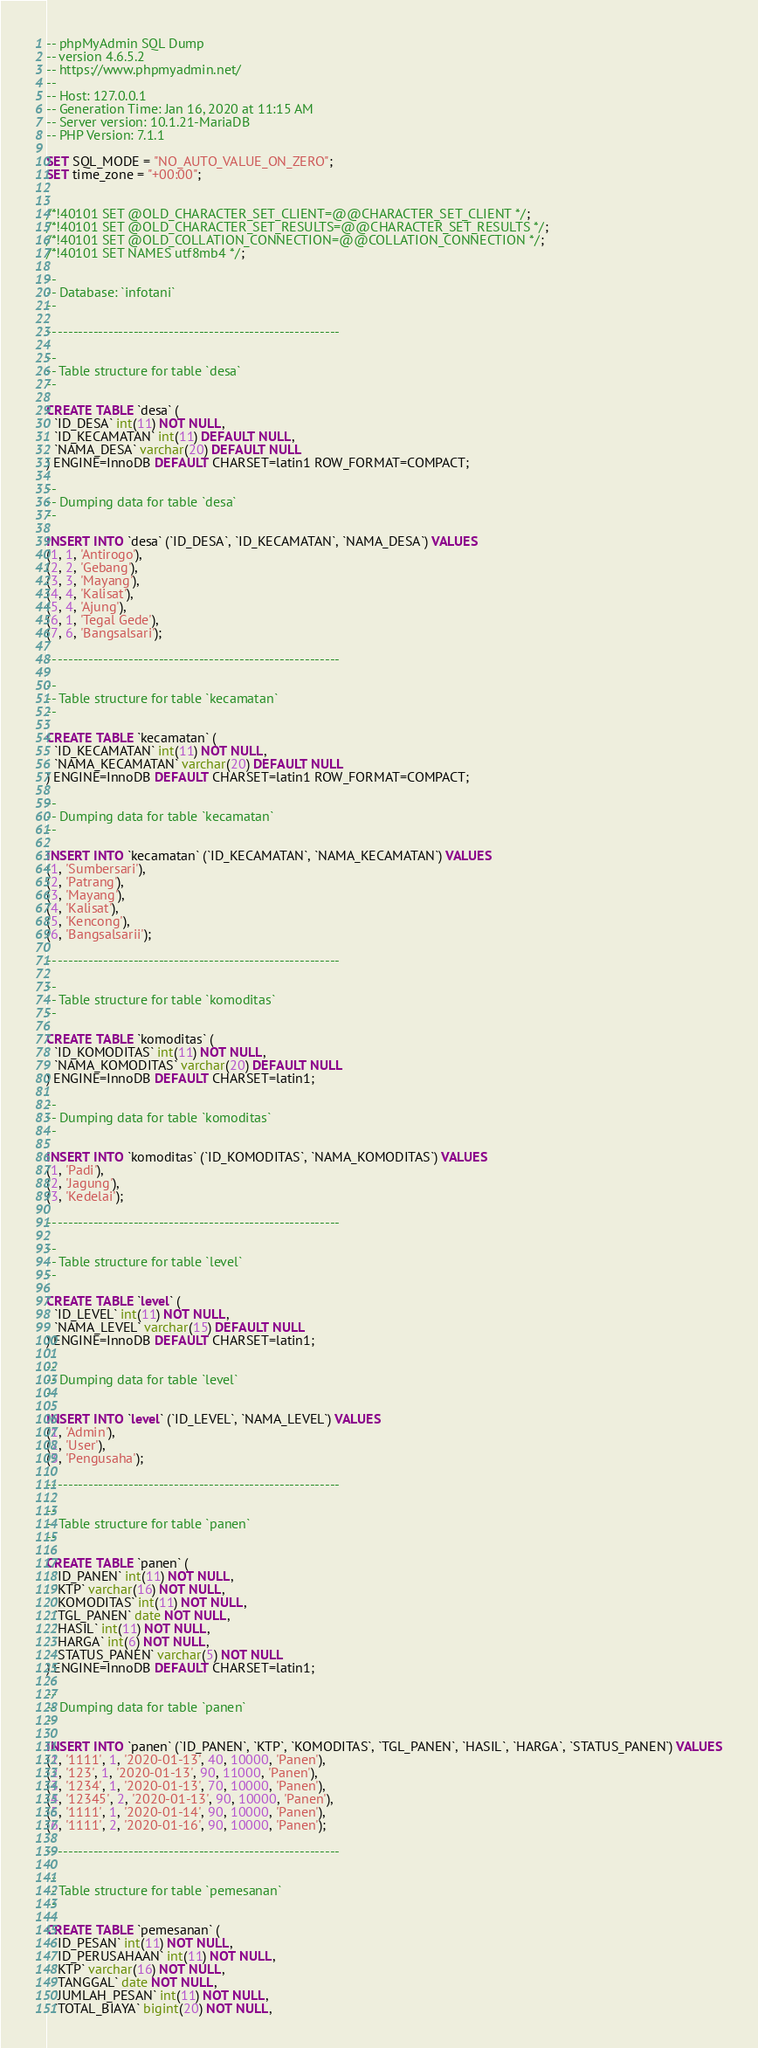Convert code to text. <code><loc_0><loc_0><loc_500><loc_500><_SQL_>-- phpMyAdmin SQL Dump
-- version 4.6.5.2
-- https://www.phpmyadmin.net/
--
-- Host: 127.0.0.1
-- Generation Time: Jan 16, 2020 at 11:15 AM
-- Server version: 10.1.21-MariaDB
-- PHP Version: 7.1.1

SET SQL_MODE = "NO_AUTO_VALUE_ON_ZERO";
SET time_zone = "+00:00";


/*!40101 SET @OLD_CHARACTER_SET_CLIENT=@@CHARACTER_SET_CLIENT */;
/*!40101 SET @OLD_CHARACTER_SET_RESULTS=@@CHARACTER_SET_RESULTS */;
/*!40101 SET @OLD_COLLATION_CONNECTION=@@COLLATION_CONNECTION */;
/*!40101 SET NAMES utf8mb4 */;

--
-- Database: `infotani`
--

-- --------------------------------------------------------

--
-- Table structure for table `desa`
--

CREATE TABLE `desa` (
  `ID_DESA` int(11) NOT NULL,
  `ID_KECAMATAN` int(11) DEFAULT NULL,
  `NAMA_DESA` varchar(20) DEFAULT NULL
) ENGINE=InnoDB DEFAULT CHARSET=latin1 ROW_FORMAT=COMPACT;

--
-- Dumping data for table `desa`
--

INSERT INTO `desa` (`ID_DESA`, `ID_KECAMATAN`, `NAMA_DESA`) VALUES
(1, 1, 'Antirogo'),
(2, 2, 'Gebang'),
(3, 3, 'Mayang'),
(4, 4, 'Kalisat'),
(5, 4, 'Ajung'),
(6, 1, 'Tegal Gede'),
(7, 6, 'Bangsalsari');

-- --------------------------------------------------------

--
-- Table structure for table `kecamatan`
--

CREATE TABLE `kecamatan` (
  `ID_KECAMATAN` int(11) NOT NULL,
  `NAMA_KECAMATAN` varchar(20) DEFAULT NULL
) ENGINE=InnoDB DEFAULT CHARSET=latin1 ROW_FORMAT=COMPACT;

--
-- Dumping data for table `kecamatan`
--

INSERT INTO `kecamatan` (`ID_KECAMATAN`, `NAMA_KECAMATAN`) VALUES
(1, 'Sumbersari'),
(2, 'Patrang'),
(3, 'Mayang'),
(4, 'Kalisat'),
(5, 'Kencong'),
(6, 'Bangsalsarii');

-- --------------------------------------------------------

--
-- Table structure for table `komoditas`
--

CREATE TABLE `komoditas` (
  `ID_KOMODITAS` int(11) NOT NULL,
  `NAMA_KOMODITAS` varchar(20) DEFAULT NULL
) ENGINE=InnoDB DEFAULT CHARSET=latin1;

--
-- Dumping data for table `komoditas`
--

INSERT INTO `komoditas` (`ID_KOMODITAS`, `NAMA_KOMODITAS`) VALUES
(1, 'Padi'),
(2, 'Jagung'),
(3, 'Kedelai');

-- --------------------------------------------------------

--
-- Table structure for table `level`
--

CREATE TABLE `level` (
  `ID_LEVEL` int(11) NOT NULL,
  `NAMA_LEVEL` varchar(15) DEFAULT NULL
) ENGINE=InnoDB DEFAULT CHARSET=latin1;

--
-- Dumping data for table `level`
--

INSERT INTO `level` (`ID_LEVEL`, `NAMA_LEVEL`) VALUES
(1, 'Admin'),
(2, 'User'),
(3, 'Pengusaha');

-- --------------------------------------------------------

--
-- Table structure for table `panen`
--

CREATE TABLE `panen` (
  `ID_PANEN` int(11) NOT NULL,
  `KTP` varchar(16) NOT NULL,
  `KOMODITAS` int(11) NOT NULL,
  `TGL_PANEN` date NOT NULL,
  `HASIL` int(11) NOT NULL,
  `HARGA` int(6) NOT NULL,
  `STATUS_PANEN` varchar(5) NOT NULL
) ENGINE=InnoDB DEFAULT CHARSET=latin1;

--
-- Dumping data for table `panen`
--

INSERT INTO `panen` (`ID_PANEN`, `KTP`, `KOMODITAS`, `TGL_PANEN`, `HASIL`, `HARGA`, `STATUS_PANEN`) VALUES
(1, '1111', 1, '2020-01-13', 40, 10000, 'Panen'),
(2, '123', 1, '2020-01-13', 90, 11000, 'Panen'),
(3, '1234', 1, '2020-01-13', 70, 10000, 'Panen'),
(4, '12345', 2, '2020-01-13', 90, 10000, 'Panen'),
(5, '1111', 1, '2020-01-14', 90, 10000, 'Panen'),
(6, '1111', 2, '2020-01-16', 90, 10000, 'Panen');

-- --------------------------------------------------------

--
-- Table structure for table `pemesanan`
--

CREATE TABLE `pemesanan` (
  `ID_PESAN` int(11) NOT NULL,
  `ID_PERUSAHAAN` int(11) NOT NULL,
  `KTP` varchar(16) NOT NULL,
  `TANGGAL` date NOT NULL,
  `JUMLAH_PESAN` int(11) NOT NULL,
  `TOTAL_BIAYA` bigint(20) NOT NULL,</code> 